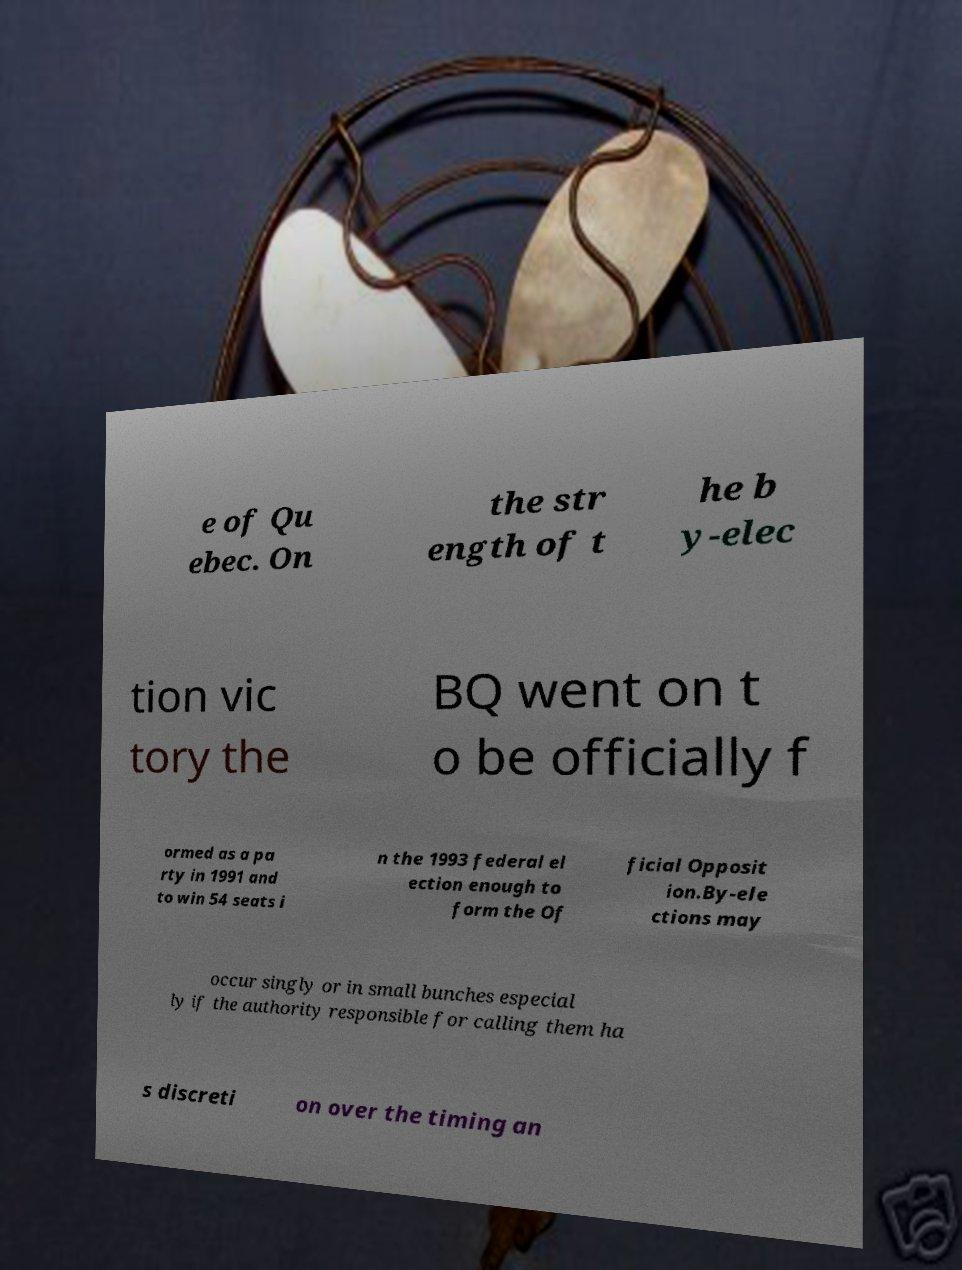Can you accurately transcribe the text from the provided image for me? e of Qu ebec. On the str ength of t he b y-elec tion vic tory the BQ went on t o be officially f ormed as a pa rty in 1991 and to win 54 seats i n the 1993 federal el ection enough to form the Of ficial Opposit ion.By-ele ctions may occur singly or in small bunches especial ly if the authority responsible for calling them ha s discreti on over the timing an 